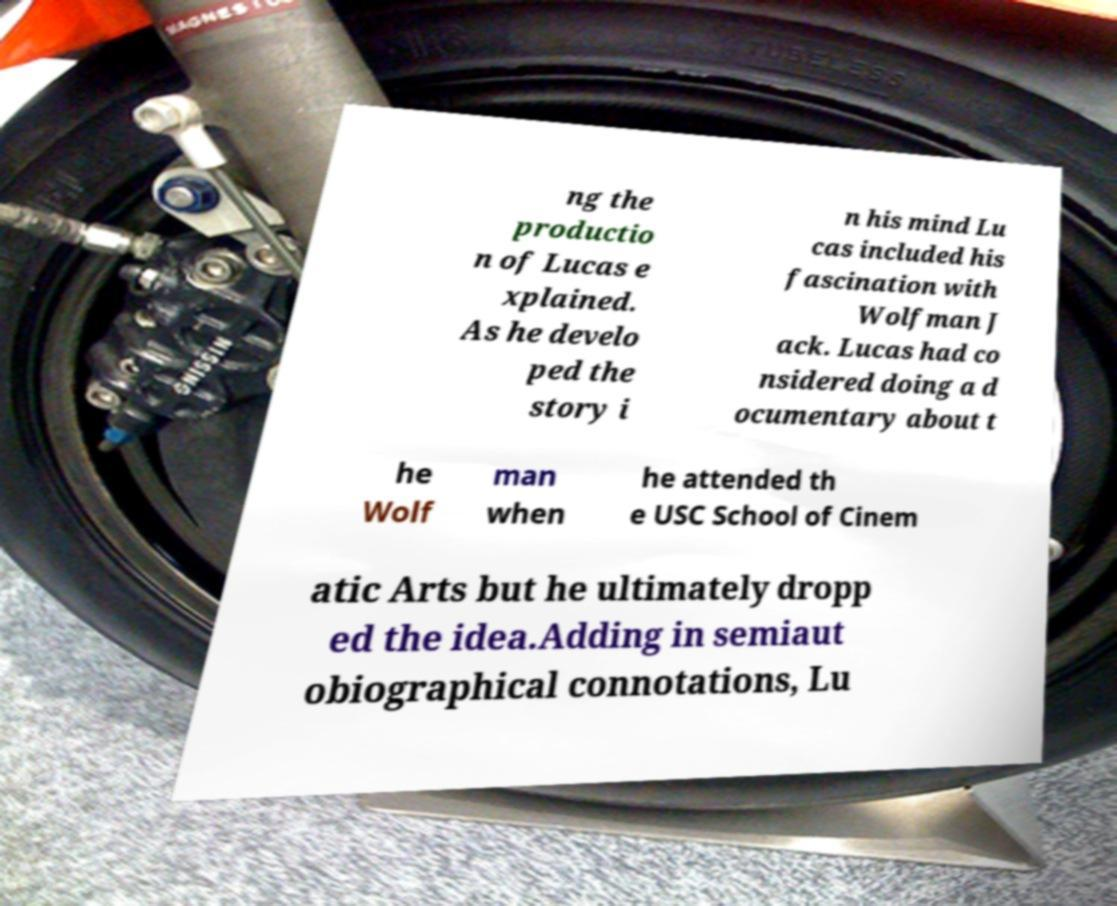There's text embedded in this image that I need extracted. Can you transcribe it verbatim? ng the productio n of Lucas e xplained. As he develo ped the story i n his mind Lu cas included his fascination with Wolfman J ack. Lucas had co nsidered doing a d ocumentary about t he Wolf man when he attended th e USC School of Cinem atic Arts but he ultimately dropp ed the idea.Adding in semiaut obiographical connotations, Lu 